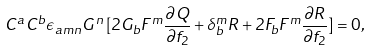Convert formula to latex. <formula><loc_0><loc_0><loc_500><loc_500>C ^ { a } C ^ { b } \epsilon _ { a m n } G ^ { n } \, [ 2 G _ { b } F ^ { m } \frac { \partial Q } { \partial f _ { 2 } } + \delta _ { b } ^ { m } R + 2 F _ { b } F ^ { m } \frac { \partial R } { \partial f _ { 2 } } ] = 0 ,</formula> 